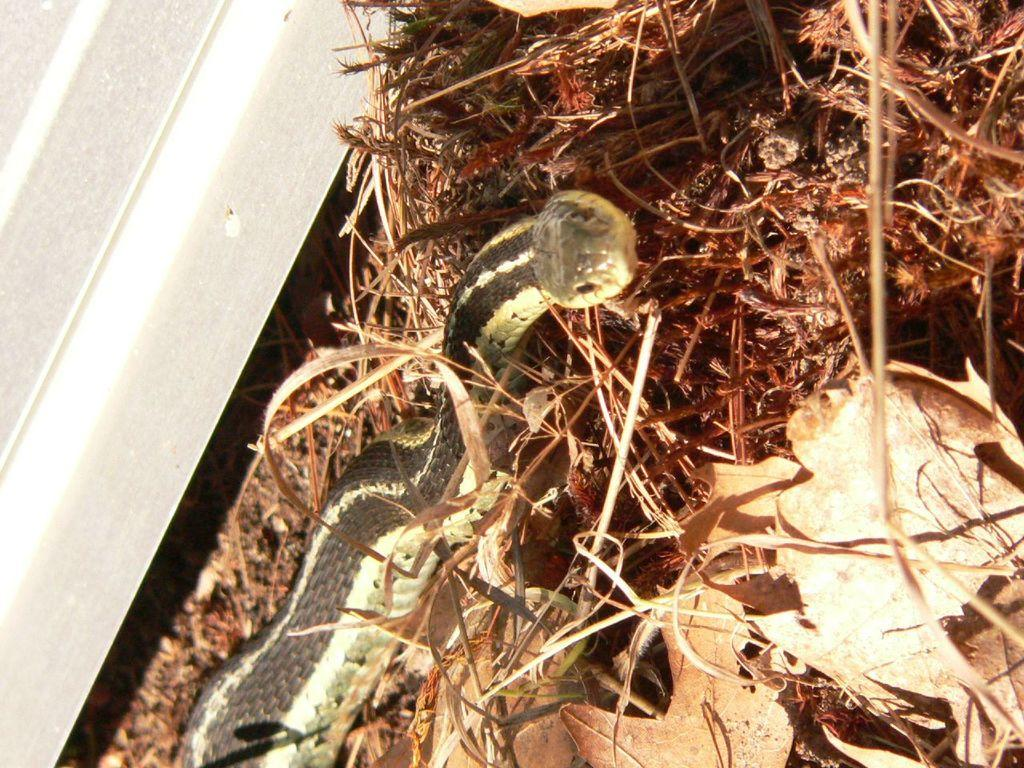What animal is present in the image? There is a snake in the image. What is the snake's environment like? The snake is on dry grass. Is there any structure or object near the snake? Yes, the snake is beside a wall. What type of account does the snake have in the image? There is no indication of an account in the image, as it features a snake on dry grass beside a wall. 